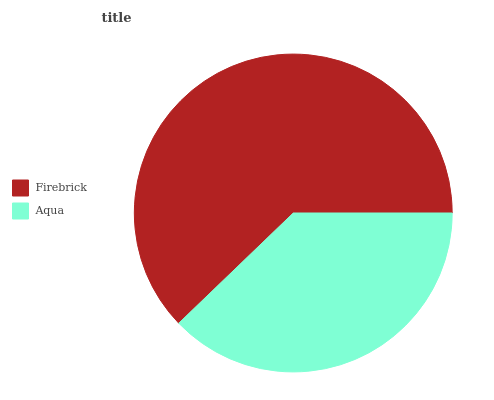Is Aqua the minimum?
Answer yes or no. Yes. Is Firebrick the maximum?
Answer yes or no. Yes. Is Aqua the maximum?
Answer yes or no. No. Is Firebrick greater than Aqua?
Answer yes or no. Yes. Is Aqua less than Firebrick?
Answer yes or no. Yes. Is Aqua greater than Firebrick?
Answer yes or no. No. Is Firebrick less than Aqua?
Answer yes or no. No. Is Firebrick the high median?
Answer yes or no. Yes. Is Aqua the low median?
Answer yes or no. Yes. Is Aqua the high median?
Answer yes or no. No. Is Firebrick the low median?
Answer yes or no. No. 